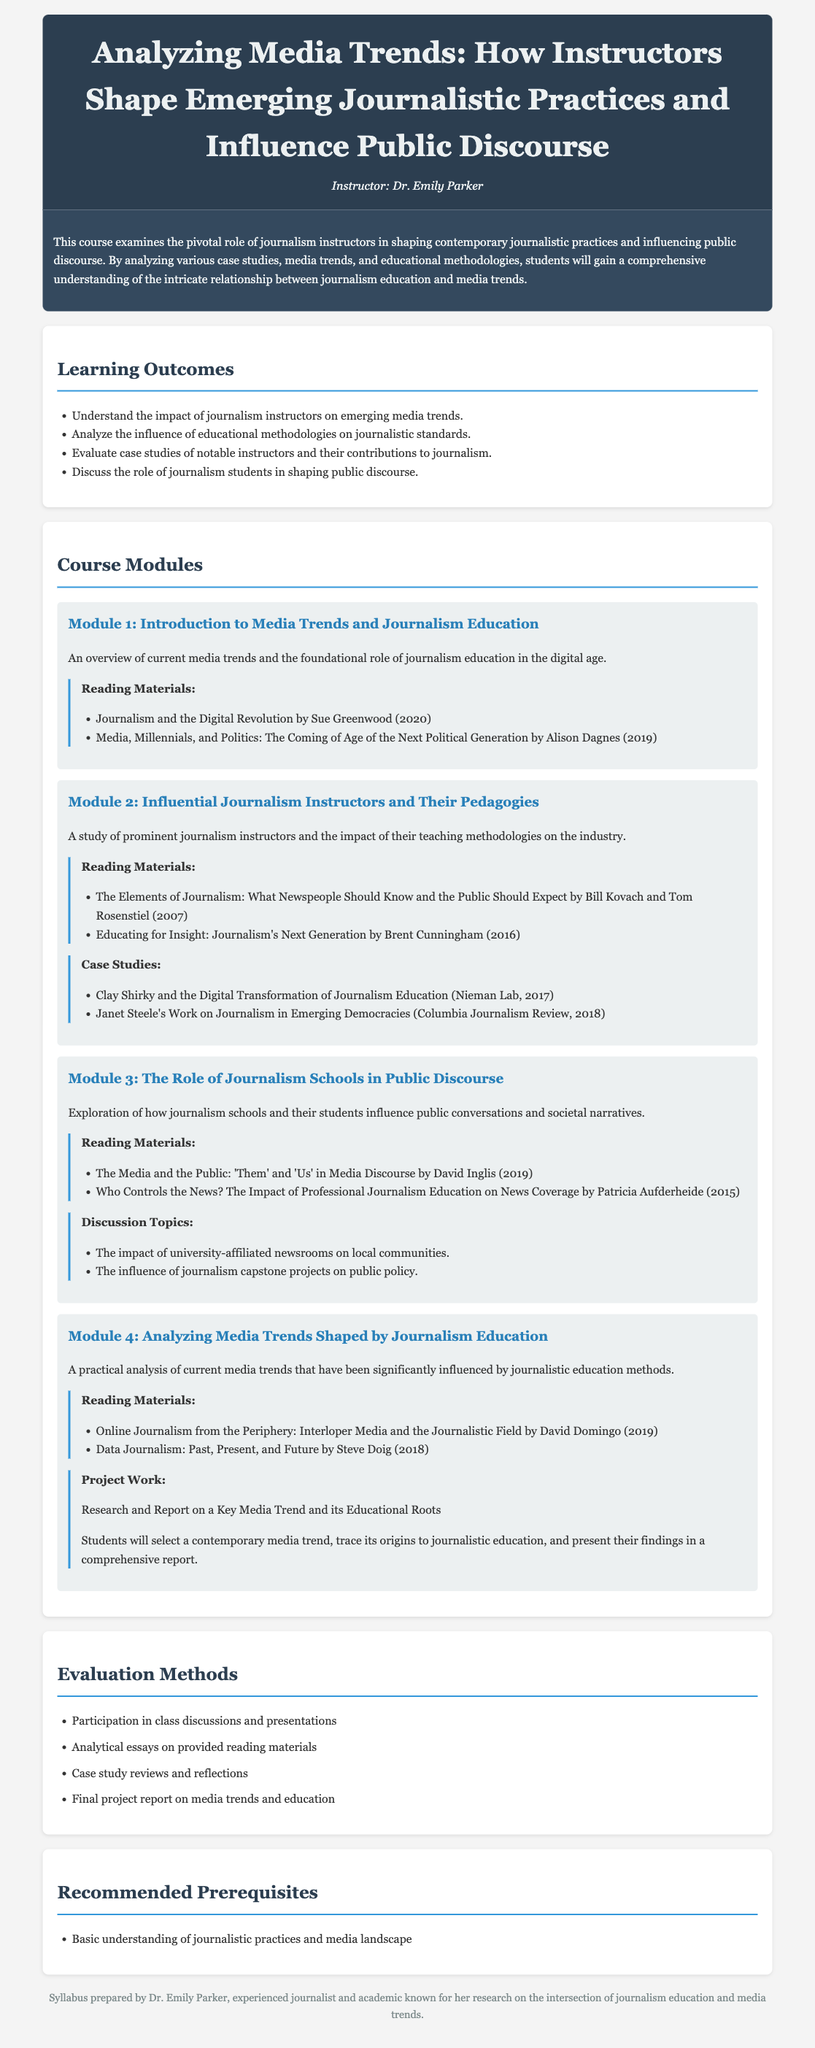What is the course title? The course title is presented in the header of the document.
Answer: Analyzing Media Trends: How Instructors Shape Emerging Journalistic Practices and Influence Public Discourse Who is the instructor of the course? The instructor's name is mentioned in the header section.
Answer: Dr. Emily Parker What year was "Journalism and the Digital Revolution" published? The publication year for the reading material is provided in parentheses next to the title.
Answer: 2020 How many learning outcomes are listed in the syllabus? The number of learning outcomes is counted from the bullet points under the Learning Outcomes section.
Answer: Four What is the main focus of Module 3? The focus of each module is briefly summarized in the module description.
Answer: Exploration of how journalism schools and their students influence public conversations and societal narratives What type of work do students need to complete in Module 4? The type of project work is explicitly stated in the module description.
Answer: Research and Report on a Key Media Trend and its Educational Roots Which reading material discusses the media's relationship with the public? The titles of relevant reading materials regarding media discourse can be found in Module 3.
Answer: The Media and the Public: 'Them' and 'Us' in Media Discourse What evaluation method requires participation in class discussions? The evaluation methods section lists specific methods used to assess students, including participation.
Answer: Participation in class discussions and presentations 